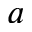Convert formula to latex. <formula><loc_0><loc_0><loc_500><loc_500>a</formula> 